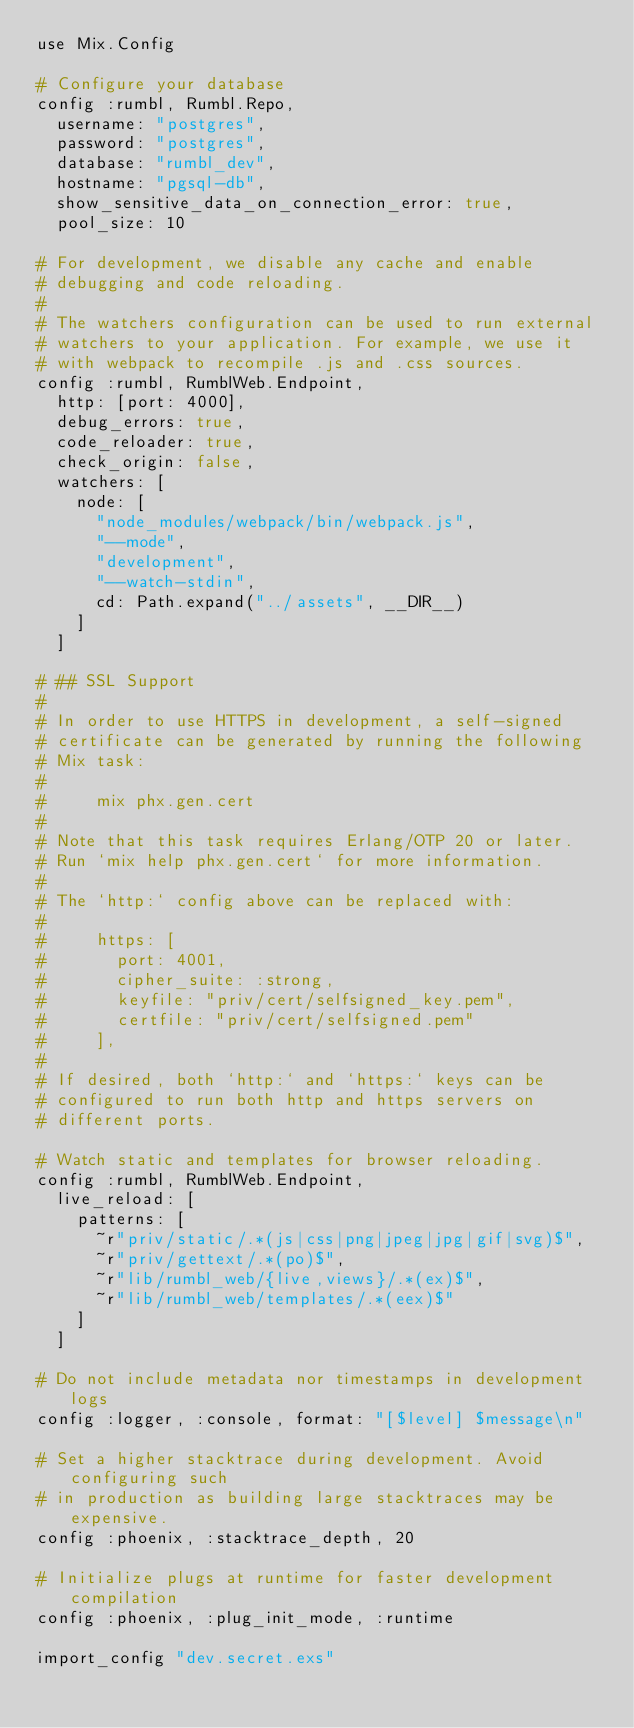<code> <loc_0><loc_0><loc_500><loc_500><_Elixir_>use Mix.Config

# Configure your database
config :rumbl, Rumbl.Repo,
  username: "postgres",
  password: "postgres",
  database: "rumbl_dev",
  hostname: "pgsql-db",
  show_sensitive_data_on_connection_error: true,
  pool_size: 10

# For development, we disable any cache and enable
# debugging and code reloading.
#
# The watchers configuration can be used to run external
# watchers to your application. For example, we use it
# with webpack to recompile .js and .css sources.
config :rumbl, RumblWeb.Endpoint,
  http: [port: 4000],
  debug_errors: true,
  code_reloader: true,
  check_origin: false,
  watchers: [
    node: [
      "node_modules/webpack/bin/webpack.js",
      "--mode",
      "development",
      "--watch-stdin",
      cd: Path.expand("../assets", __DIR__)
    ]
  ]

# ## SSL Support
#
# In order to use HTTPS in development, a self-signed
# certificate can be generated by running the following
# Mix task:
#
#     mix phx.gen.cert
#
# Note that this task requires Erlang/OTP 20 or later.
# Run `mix help phx.gen.cert` for more information.
#
# The `http:` config above can be replaced with:
#
#     https: [
#       port: 4001,
#       cipher_suite: :strong,
#       keyfile: "priv/cert/selfsigned_key.pem",
#       certfile: "priv/cert/selfsigned.pem"
#     ],
#
# If desired, both `http:` and `https:` keys can be
# configured to run both http and https servers on
# different ports.

# Watch static and templates for browser reloading.
config :rumbl, RumblWeb.Endpoint,
  live_reload: [
    patterns: [
      ~r"priv/static/.*(js|css|png|jpeg|jpg|gif|svg)$",
      ~r"priv/gettext/.*(po)$",
      ~r"lib/rumbl_web/{live,views}/.*(ex)$",
      ~r"lib/rumbl_web/templates/.*(eex)$"
    ]
  ]

# Do not include metadata nor timestamps in development logs
config :logger, :console, format: "[$level] $message\n"

# Set a higher stacktrace during development. Avoid configuring such
# in production as building large stacktraces may be expensive.
config :phoenix, :stacktrace_depth, 20

# Initialize plugs at runtime for faster development compilation
config :phoenix, :plug_init_mode, :runtime

import_config "dev.secret.exs"
</code> 